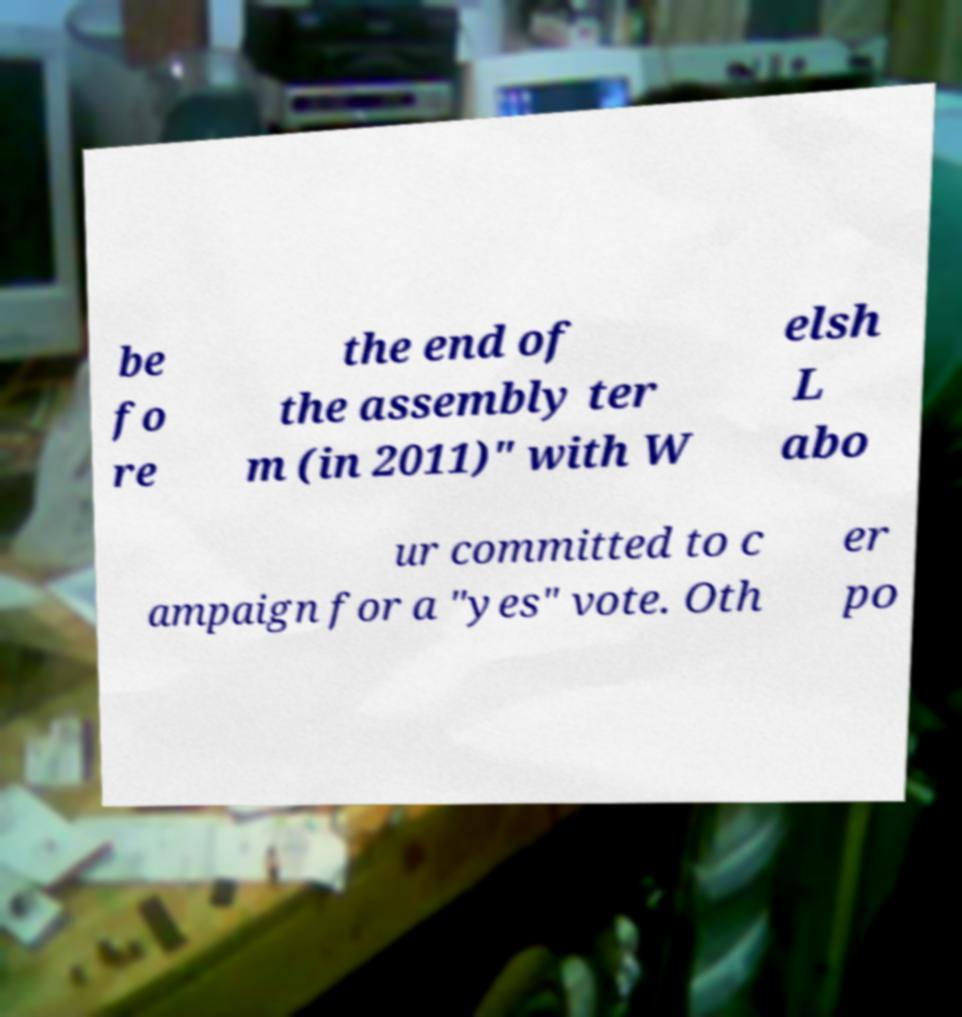I need the written content from this picture converted into text. Can you do that? be fo re the end of the assembly ter m (in 2011)" with W elsh L abo ur committed to c ampaign for a "yes" vote. Oth er po 